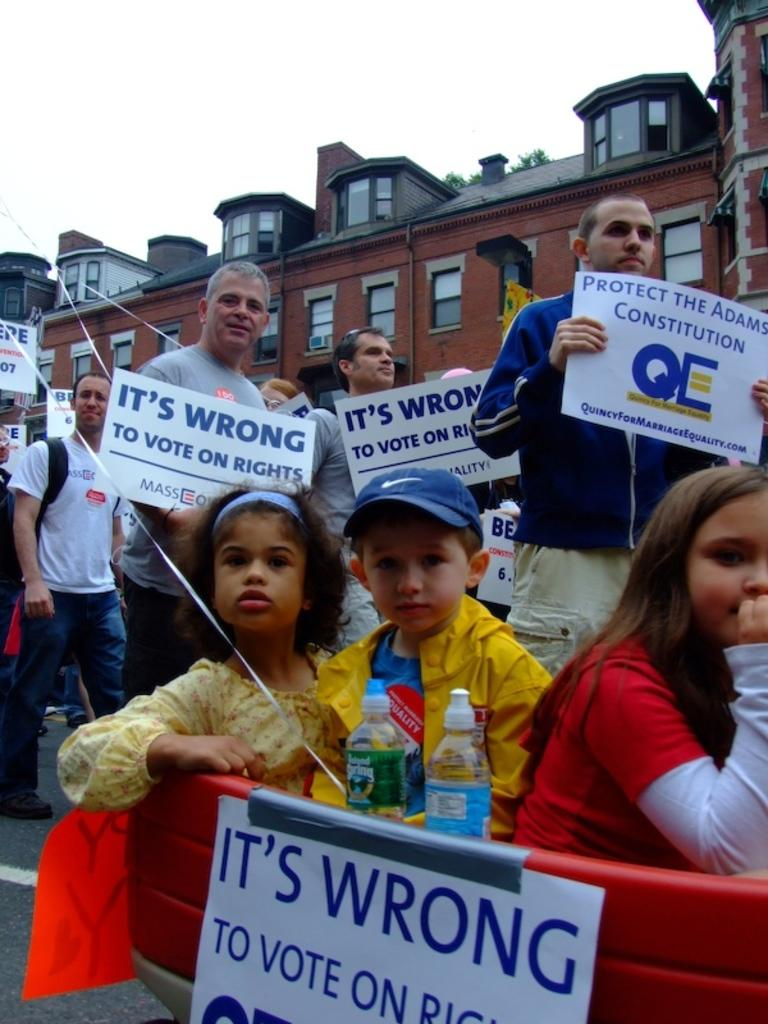What is happening in the image involving the group of people? The people in the image are holding boards in their hands. What can be seen in the background of the image? There is a building and the sky visible in the background of the image. What type of ink is being used on the boards in the image? There is no indication of ink or writing on the boards in the image, so it cannot be determined. 